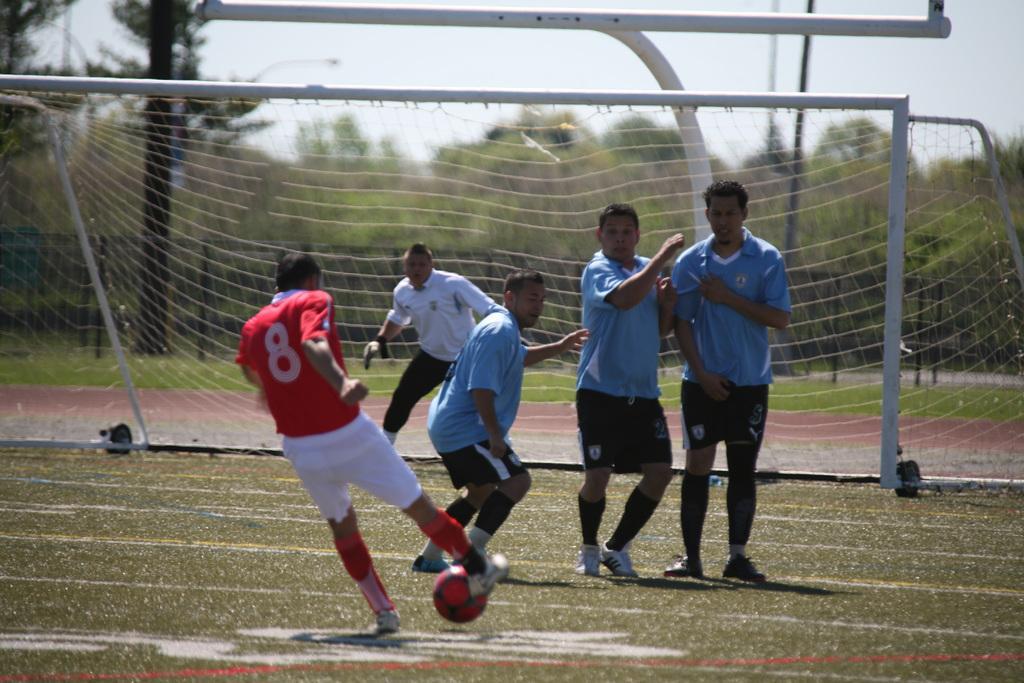Describe this image in one or two sentences. In this picture we can see some persons are playing in the ground. This is the ball. And there is a mesh. On the background we can see some trees. And this is the sky. 